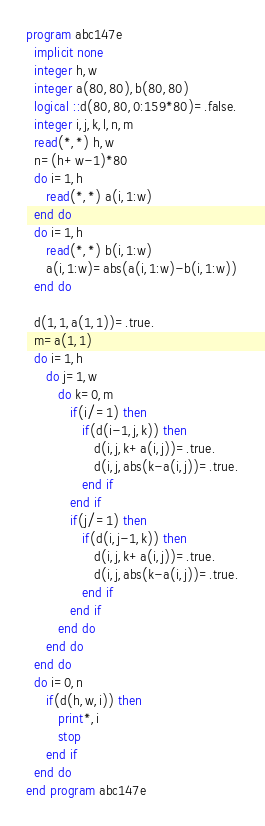Convert code to text. <code><loc_0><loc_0><loc_500><loc_500><_FORTRAN_>program abc147e
  implicit none
  integer h,w
  integer a(80,80),b(80,80)
  logical ::d(80,80,0:159*80)=.false.
  integer i,j,k,l,n,m
  read(*,*) h,w
  n=(h+w-1)*80
  do i=1,h
     read(*,*) a(i,1:w)
  end do
  do i=1,h
     read(*,*) b(i,1:w)
     a(i,1:w)=abs(a(i,1:w)-b(i,1:w))
  end do
  
  d(1,1,a(1,1))=.true.
  m=a(1,1)
  do i=1,h
     do j=1,w
        do k=0,m
           if(i/=1) then
              if(d(i-1,j,k)) then
                 d(i,j,k+a(i,j))=.true.
                 d(i,j,abs(k-a(i,j))=.true.
              end if
           end if
           if(j/=1) then
              if(d(i,j-1,k)) then
                 d(i,j,k+a(i,j))=.true.
                 d(i,j,abs(k-a(i,j))=.true.
              end if
           end if
        end do
     end do
  end do
  do i=0,n
     if(d(h,w,i)) then
        print*,i
        stop
     end if
  end do
end program abc147e


</code> 